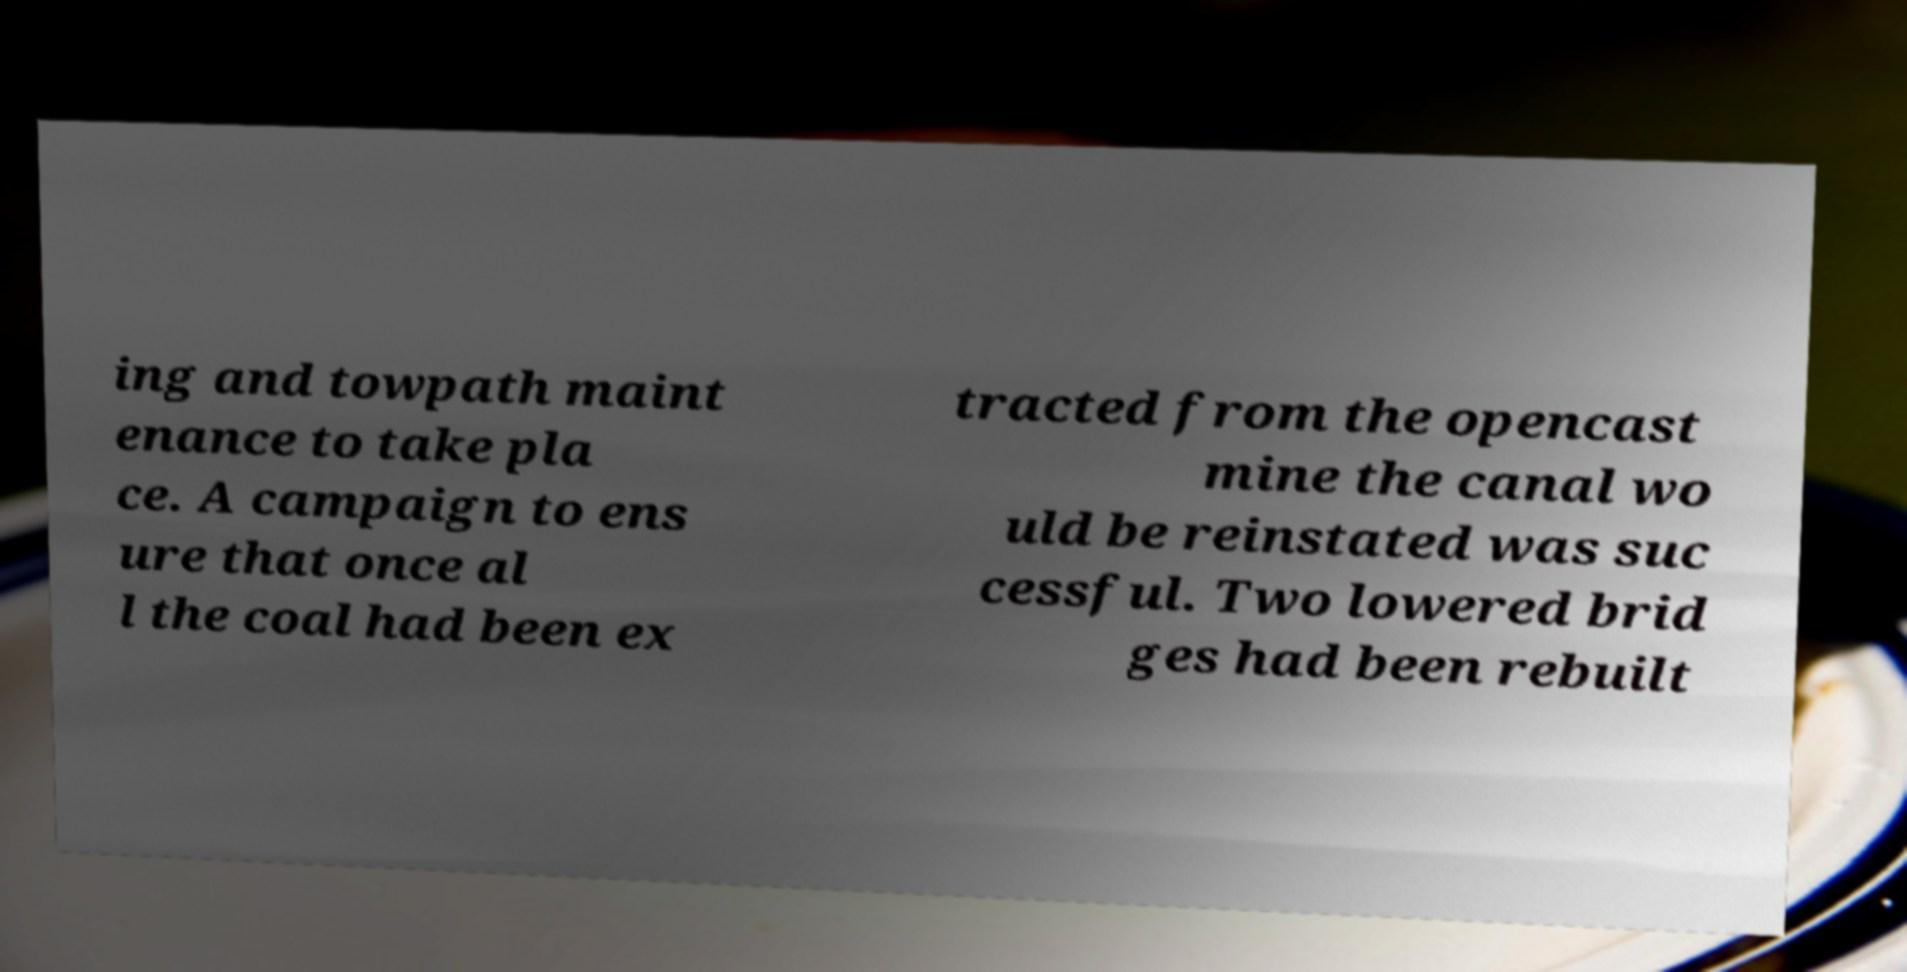Can you accurately transcribe the text from the provided image for me? ing and towpath maint enance to take pla ce. A campaign to ens ure that once al l the coal had been ex tracted from the opencast mine the canal wo uld be reinstated was suc cessful. Two lowered brid ges had been rebuilt 